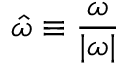Convert formula to latex. <formula><loc_0><loc_0><loc_500><loc_500>\hat { \omega } \equiv \frac { \omega } { | \omega | }</formula> 